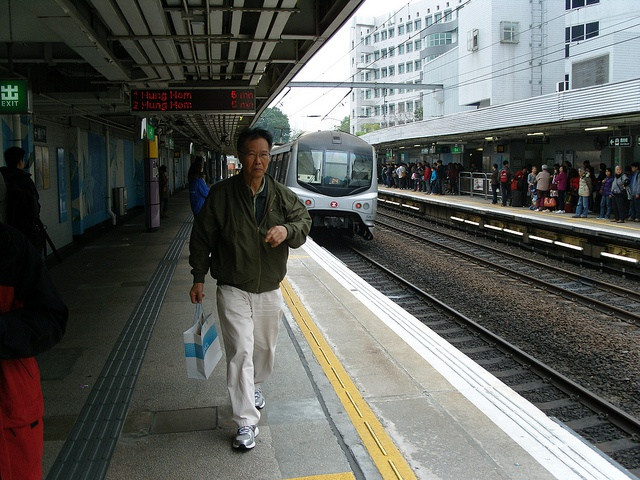Describe the objects in this image and their specific colors. I can see people in black, darkgray, gray, and lightgray tones, people in maroon and black tones, train in black, gray, and darkgray tones, people in black, gray, maroon, and purple tones, and people in black, maroon, and gray tones in this image. 